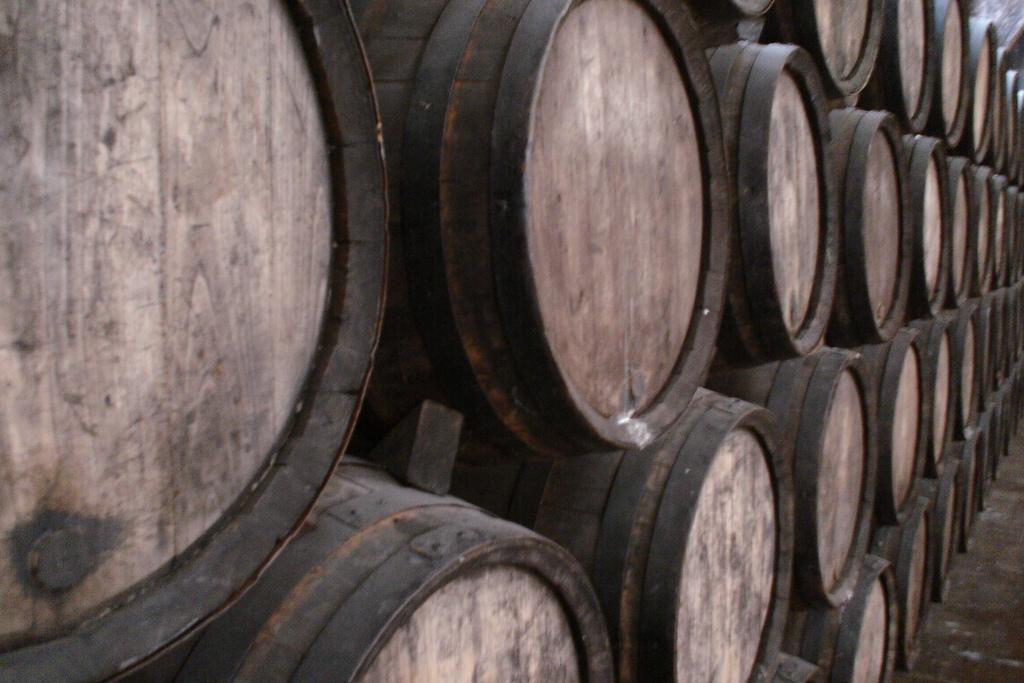Can you describe this image briefly? In this image I can see the black colored wooden surface to which I can see number of wooden bowls are hanged which are black and brown in color. To the right bottom of the image I can see the wooden surface. 